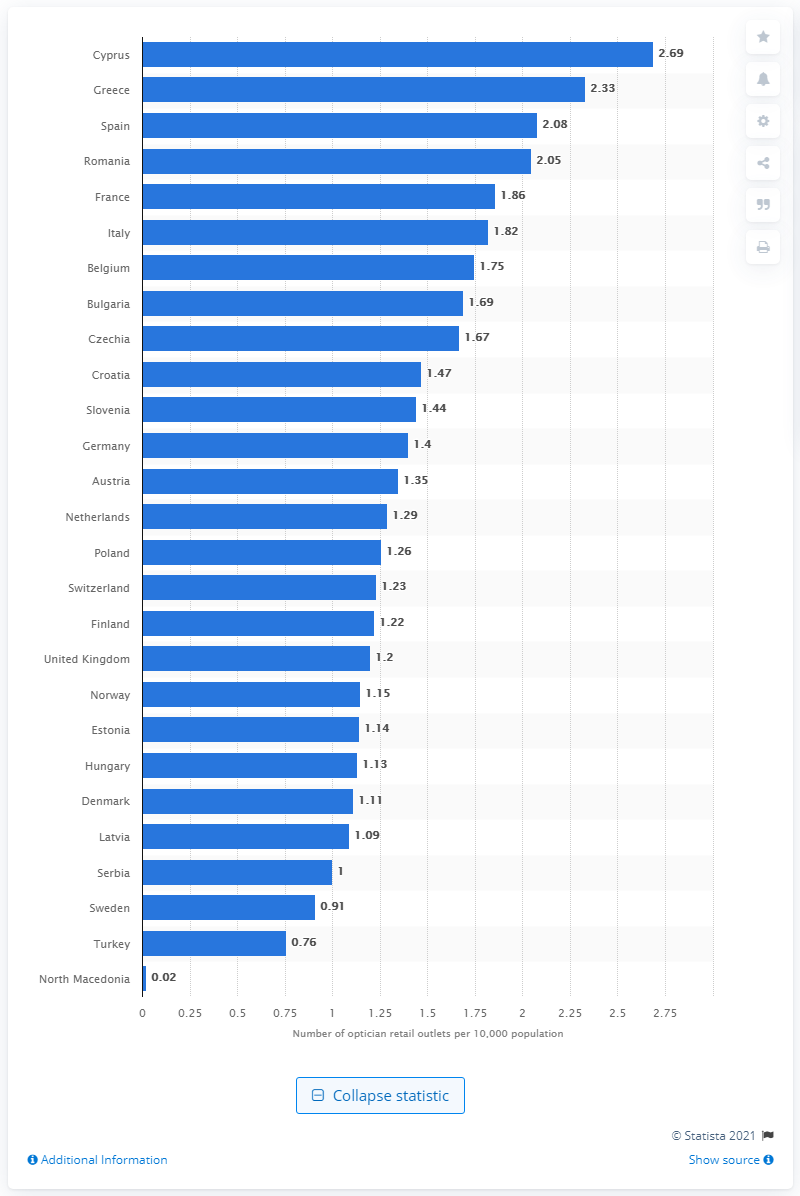Outline some significant characteristics in this image. According to the data from 2020, Cyprus had the highest number of retail outlets, making it the top country in this regard. In 2020, Greece had the highest number of optical retail outlets per 10,000 population, making it the country with the most optical retail outlets relative to its population. 